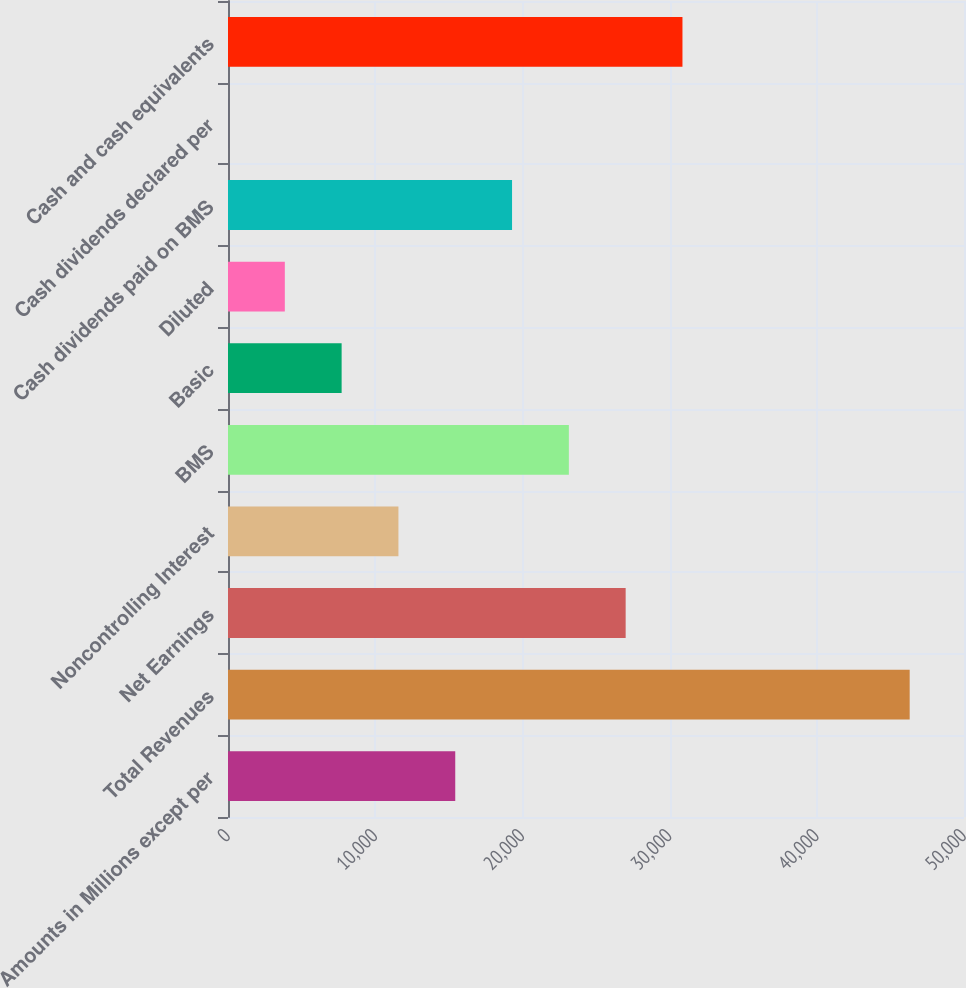<chart> <loc_0><loc_0><loc_500><loc_500><bar_chart><fcel>Amounts in Millions except per<fcel>Total Revenues<fcel>Net Earnings<fcel>Noncontrolling Interest<fcel>BMS<fcel>Basic<fcel>Diluted<fcel>Cash dividends paid on BMS<fcel>Cash dividends declared per<fcel>Cash and cash equivalents<nl><fcel>15437.6<fcel>46310.1<fcel>27014.8<fcel>11578.6<fcel>23155.8<fcel>7719.53<fcel>3860.47<fcel>19296.7<fcel>1.41<fcel>30873.9<nl></chart> 